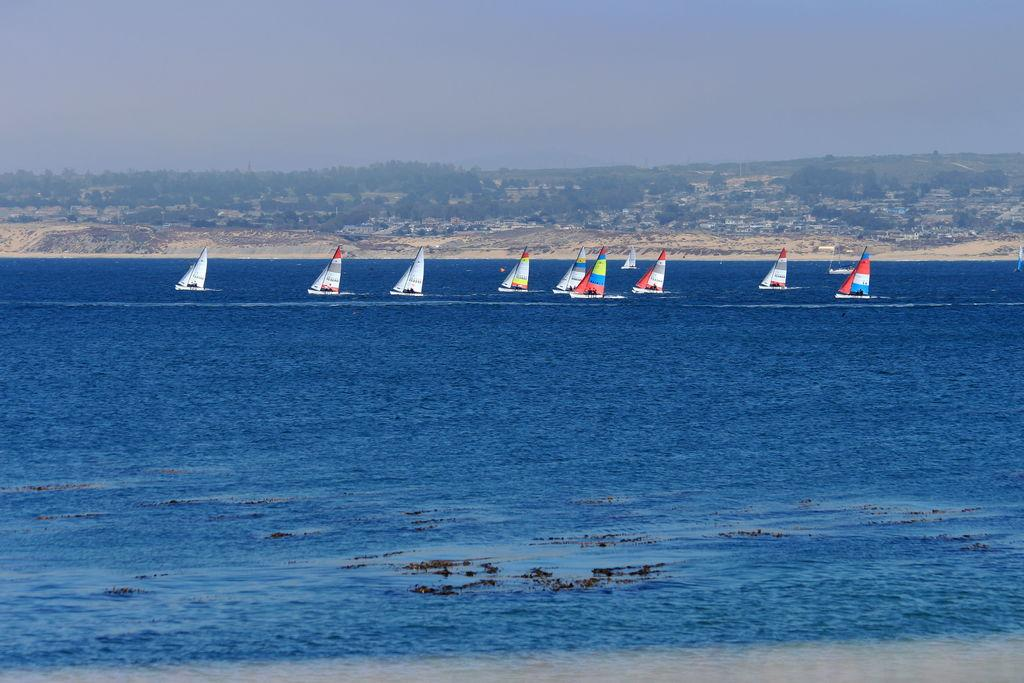What type of vehicles are in the image? There are boats in the image. What feature do the boats have? The boats have masts. What is the primary setting of the image? There is water in the image. What can be seen in the background of the image? There are trees and the ground visible in the background. What is the condition of the sky in the image? The sky is blue with clouds. What type of glove can be seen hanging from the mast of the boat in the image? There is no glove present on the boat or hanging from the mast in the image. What type of bird can be seen flying over the water in the image? There are no birds visible in the image; it only features boats on the water. 